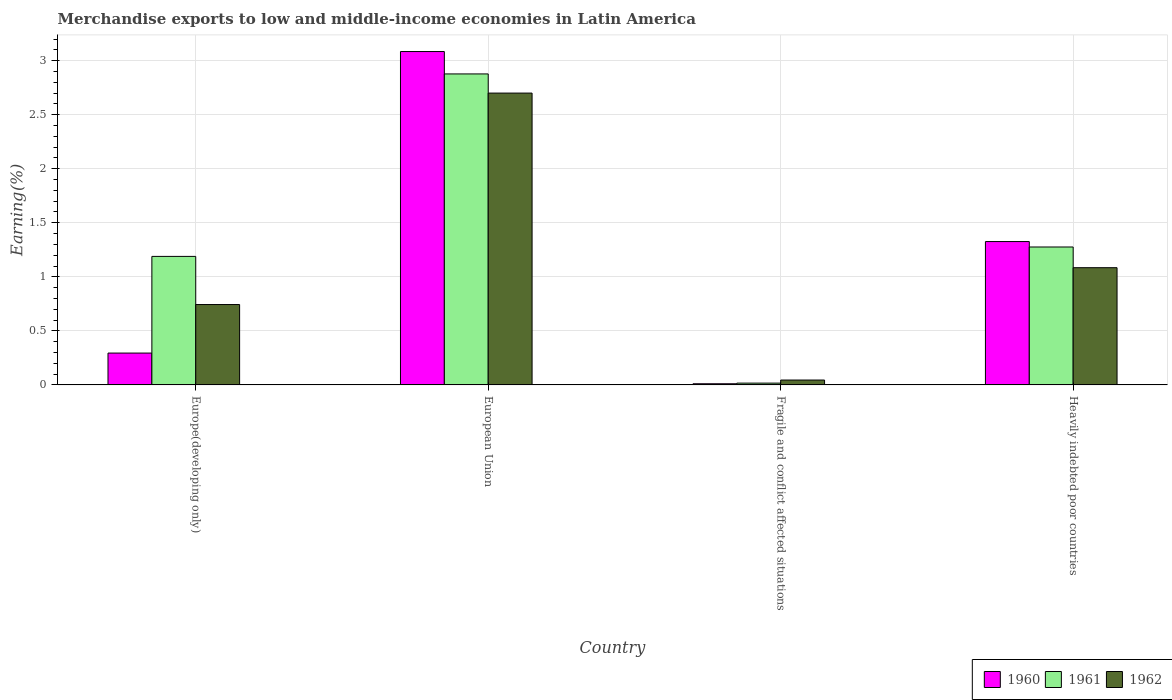How many groups of bars are there?
Give a very brief answer. 4. How many bars are there on the 2nd tick from the left?
Offer a terse response. 3. What is the label of the 4th group of bars from the left?
Provide a short and direct response. Heavily indebted poor countries. In how many cases, is the number of bars for a given country not equal to the number of legend labels?
Give a very brief answer. 0. What is the percentage of amount earned from merchandise exports in 1961 in European Union?
Provide a succinct answer. 2.88. Across all countries, what is the maximum percentage of amount earned from merchandise exports in 1961?
Ensure brevity in your answer.  2.88. Across all countries, what is the minimum percentage of amount earned from merchandise exports in 1960?
Your response must be concise. 0.01. In which country was the percentage of amount earned from merchandise exports in 1960 maximum?
Give a very brief answer. European Union. In which country was the percentage of amount earned from merchandise exports in 1961 minimum?
Offer a terse response. Fragile and conflict affected situations. What is the total percentage of amount earned from merchandise exports in 1962 in the graph?
Make the answer very short. 4.57. What is the difference between the percentage of amount earned from merchandise exports in 1961 in Europe(developing only) and that in European Union?
Provide a succinct answer. -1.69. What is the difference between the percentage of amount earned from merchandise exports in 1962 in European Union and the percentage of amount earned from merchandise exports in 1960 in Heavily indebted poor countries?
Your answer should be compact. 1.37. What is the average percentage of amount earned from merchandise exports in 1961 per country?
Keep it short and to the point. 1.34. What is the difference between the percentage of amount earned from merchandise exports of/in 1962 and percentage of amount earned from merchandise exports of/in 1961 in European Union?
Ensure brevity in your answer.  -0.18. In how many countries, is the percentage of amount earned from merchandise exports in 1960 greater than 3.1 %?
Your answer should be compact. 0. What is the ratio of the percentage of amount earned from merchandise exports in 1960 in Europe(developing only) to that in Heavily indebted poor countries?
Provide a short and direct response. 0.22. What is the difference between the highest and the second highest percentage of amount earned from merchandise exports in 1961?
Give a very brief answer. -1.6. What is the difference between the highest and the lowest percentage of amount earned from merchandise exports in 1960?
Provide a short and direct response. 3.07. In how many countries, is the percentage of amount earned from merchandise exports in 1961 greater than the average percentage of amount earned from merchandise exports in 1961 taken over all countries?
Make the answer very short. 1. What does the 2nd bar from the left in European Union represents?
Keep it short and to the point. 1961. What does the 3rd bar from the right in Fragile and conflict affected situations represents?
Make the answer very short. 1960. How many bars are there?
Your response must be concise. 12. Are all the bars in the graph horizontal?
Give a very brief answer. No. How many countries are there in the graph?
Provide a short and direct response. 4. What is the difference between two consecutive major ticks on the Y-axis?
Offer a terse response. 0.5. What is the title of the graph?
Offer a terse response. Merchandise exports to low and middle-income economies in Latin America. What is the label or title of the Y-axis?
Make the answer very short. Earning(%). What is the Earning(%) of 1960 in Europe(developing only)?
Your answer should be compact. 0.29. What is the Earning(%) in 1961 in Europe(developing only)?
Provide a short and direct response. 1.19. What is the Earning(%) in 1962 in Europe(developing only)?
Offer a very short reply. 0.74. What is the Earning(%) of 1960 in European Union?
Your answer should be very brief. 3.08. What is the Earning(%) of 1961 in European Union?
Offer a terse response. 2.88. What is the Earning(%) of 1962 in European Union?
Offer a very short reply. 2.7. What is the Earning(%) of 1960 in Fragile and conflict affected situations?
Offer a terse response. 0.01. What is the Earning(%) of 1961 in Fragile and conflict affected situations?
Your response must be concise. 0.02. What is the Earning(%) of 1962 in Fragile and conflict affected situations?
Your answer should be very brief. 0.05. What is the Earning(%) in 1960 in Heavily indebted poor countries?
Your answer should be very brief. 1.33. What is the Earning(%) of 1961 in Heavily indebted poor countries?
Offer a terse response. 1.28. What is the Earning(%) of 1962 in Heavily indebted poor countries?
Provide a succinct answer. 1.08. Across all countries, what is the maximum Earning(%) in 1960?
Your answer should be compact. 3.08. Across all countries, what is the maximum Earning(%) in 1961?
Offer a terse response. 2.88. Across all countries, what is the maximum Earning(%) of 1962?
Provide a succinct answer. 2.7. Across all countries, what is the minimum Earning(%) in 1960?
Give a very brief answer. 0.01. Across all countries, what is the minimum Earning(%) of 1961?
Make the answer very short. 0.02. Across all countries, what is the minimum Earning(%) of 1962?
Your answer should be compact. 0.05. What is the total Earning(%) in 1960 in the graph?
Offer a terse response. 4.72. What is the total Earning(%) of 1961 in the graph?
Provide a succinct answer. 5.36. What is the total Earning(%) of 1962 in the graph?
Give a very brief answer. 4.57. What is the difference between the Earning(%) in 1960 in Europe(developing only) and that in European Union?
Your answer should be very brief. -2.79. What is the difference between the Earning(%) of 1961 in Europe(developing only) and that in European Union?
Give a very brief answer. -1.69. What is the difference between the Earning(%) in 1962 in Europe(developing only) and that in European Union?
Provide a short and direct response. -1.96. What is the difference between the Earning(%) in 1960 in Europe(developing only) and that in Fragile and conflict affected situations?
Your answer should be compact. 0.28. What is the difference between the Earning(%) of 1961 in Europe(developing only) and that in Fragile and conflict affected situations?
Offer a very short reply. 1.17. What is the difference between the Earning(%) of 1962 in Europe(developing only) and that in Fragile and conflict affected situations?
Keep it short and to the point. 0.7. What is the difference between the Earning(%) of 1960 in Europe(developing only) and that in Heavily indebted poor countries?
Give a very brief answer. -1.03. What is the difference between the Earning(%) in 1961 in Europe(developing only) and that in Heavily indebted poor countries?
Make the answer very short. -0.09. What is the difference between the Earning(%) of 1962 in Europe(developing only) and that in Heavily indebted poor countries?
Provide a succinct answer. -0.34. What is the difference between the Earning(%) in 1960 in European Union and that in Fragile and conflict affected situations?
Your answer should be compact. 3.07. What is the difference between the Earning(%) of 1961 in European Union and that in Fragile and conflict affected situations?
Provide a succinct answer. 2.86. What is the difference between the Earning(%) in 1962 in European Union and that in Fragile and conflict affected situations?
Offer a very short reply. 2.65. What is the difference between the Earning(%) in 1960 in European Union and that in Heavily indebted poor countries?
Give a very brief answer. 1.76. What is the difference between the Earning(%) of 1961 in European Union and that in Heavily indebted poor countries?
Offer a very short reply. 1.6. What is the difference between the Earning(%) in 1962 in European Union and that in Heavily indebted poor countries?
Offer a terse response. 1.62. What is the difference between the Earning(%) in 1960 in Fragile and conflict affected situations and that in Heavily indebted poor countries?
Offer a very short reply. -1.32. What is the difference between the Earning(%) in 1961 in Fragile and conflict affected situations and that in Heavily indebted poor countries?
Give a very brief answer. -1.26. What is the difference between the Earning(%) of 1962 in Fragile and conflict affected situations and that in Heavily indebted poor countries?
Make the answer very short. -1.04. What is the difference between the Earning(%) of 1960 in Europe(developing only) and the Earning(%) of 1961 in European Union?
Provide a short and direct response. -2.58. What is the difference between the Earning(%) in 1960 in Europe(developing only) and the Earning(%) in 1962 in European Union?
Give a very brief answer. -2.41. What is the difference between the Earning(%) in 1961 in Europe(developing only) and the Earning(%) in 1962 in European Union?
Make the answer very short. -1.51. What is the difference between the Earning(%) of 1960 in Europe(developing only) and the Earning(%) of 1961 in Fragile and conflict affected situations?
Your response must be concise. 0.28. What is the difference between the Earning(%) in 1960 in Europe(developing only) and the Earning(%) in 1962 in Fragile and conflict affected situations?
Ensure brevity in your answer.  0.25. What is the difference between the Earning(%) in 1961 in Europe(developing only) and the Earning(%) in 1962 in Fragile and conflict affected situations?
Provide a short and direct response. 1.14. What is the difference between the Earning(%) in 1960 in Europe(developing only) and the Earning(%) in 1961 in Heavily indebted poor countries?
Provide a short and direct response. -0.98. What is the difference between the Earning(%) of 1960 in Europe(developing only) and the Earning(%) of 1962 in Heavily indebted poor countries?
Your answer should be compact. -0.79. What is the difference between the Earning(%) of 1961 in Europe(developing only) and the Earning(%) of 1962 in Heavily indebted poor countries?
Your response must be concise. 0.1. What is the difference between the Earning(%) of 1960 in European Union and the Earning(%) of 1961 in Fragile and conflict affected situations?
Offer a very short reply. 3.07. What is the difference between the Earning(%) of 1960 in European Union and the Earning(%) of 1962 in Fragile and conflict affected situations?
Provide a short and direct response. 3.04. What is the difference between the Earning(%) in 1961 in European Union and the Earning(%) in 1962 in Fragile and conflict affected situations?
Provide a short and direct response. 2.83. What is the difference between the Earning(%) of 1960 in European Union and the Earning(%) of 1961 in Heavily indebted poor countries?
Keep it short and to the point. 1.81. What is the difference between the Earning(%) in 1960 in European Union and the Earning(%) in 1962 in Heavily indebted poor countries?
Offer a very short reply. 2. What is the difference between the Earning(%) in 1961 in European Union and the Earning(%) in 1962 in Heavily indebted poor countries?
Provide a short and direct response. 1.79. What is the difference between the Earning(%) in 1960 in Fragile and conflict affected situations and the Earning(%) in 1961 in Heavily indebted poor countries?
Keep it short and to the point. -1.27. What is the difference between the Earning(%) in 1960 in Fragile and conflict affected situations and the Earning(%) in 1962 in Heavily indebted poor countries?
Offer a very short reply. -1.07. What is the difference between the Earning(%) of 1961 in Fragile and conflict affected situations and the Earning(%) of 1962 in Heavily indebted poor countries?
Your answer should be very brief. -1.07. What is the average Earning(%) in 1960 per country?
Your response must be concise. 1.18. What is the average Earning(%) in 1961 per country?
Provide a short and direct response. 1.34. What is the average Earning(%) of 1962 per country?
Provide a succinct answer. 1.14. What is the difference between the Earning(%) of 1960 and Earning(%) of 1961 in Europe(developing only)?
Ensure brevity in your answer.  -0.89. What is the difference between the Earning(%) of 1960 and Earning(%) of 1962 in Europe(developing only)?
Provide a succinct answer. -0.45. What is the difference between the Earning(%) of 1961 and Earning(%) of 1962 in Europe(developing only)?
Ensure brevity in your answer.  0.45. What is the difference between the Earning(%) in 1960 and Earning(%) in 1961 in European Union?
Provide a short and direct response. 0.21. What is the difference between the Earning(%) of 1960 and Earning(%) of 1962 in European Union?
Make the answer very short. 0.38. What is the difference between the Earning(%) in 1961 and Earning(%) in 1962 in European Union?
Offer a terse response. 0.18. What is the difference between the Earning(%) in 1960 and Earning(%) in 1961 in Fragile and conflict affected situations?
Provide a short and direct response. -0.01. What is the difference between the Earning(%) in 1960 and Earning(%) in 1962 in Fragile and conflict affected situations?
Your answer should be compact. -0.03. What is the difference between the Earning(%) in 1961 and Earning(%) in 1962 in Fragile and conflict affected situations?
Your response must be concise. -0.03. What is the difference between the Earning(%) of 1960 and Earning(%) of 1961 in Heavily indebted poor countries?
Keep it short and to the point. 0.05. What is the difference between the Earning(%) in 1960 and Earning(%) in 1962 in Heavily indebted poor countries?
Offer a terse response. 0.24. What is the difference between the Earning(%) in 1961 and Earning(%) in 1962 in Heavily indebted poor countries?
Provide a succinct answer. 0.19. What is the ratio of the Earning(%) of 1960 in Europe(developing only) to that in European Union?
Your response must be concise. 0.1. What is the ratio of the Earning(%) of 1961 in Europe(developing only) to that in European Union?
Give a very brief answer. 0.41. What is the ratio of the Earning(%) in 1962 in Europe(developing only) to that in European Union?
Your response must be concise. 0.28. What is the ratio of the Earning(%) of 1960 in Europe(developing only) to that in Fragile and conflict affected situations?
Offer a very short reply. 27.68. What is the ratio of the Earning(%) in 1961 in Europe(developing only) to that in Fragile and conflict affected situations?
Your response must be concise. 71.45. What is the ratio of the Earning(%) in 1962 in Europe(developing only) to that in Fragile and conflict affected situations?
Make the answer very short. 16.47. What is the ratio of the Earning(%) of 1960 in Europe(developing only) to that in Heavily indebted poor countries?
Your answer should be very brief. 0.22. What is the ratio of the Earning(%) in 1961 in Europe(developing only) to that in Heavily indebted poor countries?
Offer a terse response. 0.93. What is the ratio of the Earning(%) in 1962 in Europe(developing only) to that in Heavily indebted poor countries?
Provide a succinct answer. 0.69. What is the ratio of the Earning(%) in 1960 in European Union to that in Fragile and conflict affected situations?
Ensure brevity in your answer.  289.8. What is the ratio of the Earning(%) of 1961 in European Union to that in Fragile and conflict affected situations?
Offer a terse response. 172.89. What is the ratio of the Earning(%) in 1962 in European Union to that in Fragile and conflict affected situations?
Give a very brief answer. 59.81. What is the ratio of the Earning(%) in 1960 in European Union to that in Heavily indebted poor countries?
Offer a very short reply. 2.33. What is the ratio of the Earning(%) of 1961 in European Union to that in Heavily indebted poor countries?
Offer a very short reply. 2.25. What is the ratio of the Earning(%) in 1962 in European Union to that in Heavily indebted poor countries?
Your response must be concise. 2.49. What is the ratio of the Earning(%) of 1960 in Fragile and conflict affected situations to that in Heavily indebted poor countries?
Your answer should be very brief. 0.01. What is the ratio of the Earning(%) in 1961 in Fragile and conflict affected situations to that in Heavily indebted poor countries?
Keep it short and to the point. 0.01. What is the ratio of the Earning(%) of 1962 in Fragile and conflict affected situations to that in Heavily indebted poor countries?
Offer a very short reply. 0.04. What is the difference between the highest and the second highest Earning(%) of 1960?
Your answer should be compact. 1.76. What is the difference between the highest and the second highest Earning(%) of 1961?
Offer a very short reply. 1.6. What is the difference between the highest and the second highest Earning(%) in 1962?
Ensure brevity in your answer.  1.62. What is the difference between the highest and the lowest Earning(%) in 1960?
Your answer should be very brief. 3.07. What is the difference between the highest and the lowest Earning(%) in 1961?
Provide a succinct answer. 2.86. What is the difference between the highest and the lowest Earning(%) of 1962?
Provide a short and direct response. 2.65. 